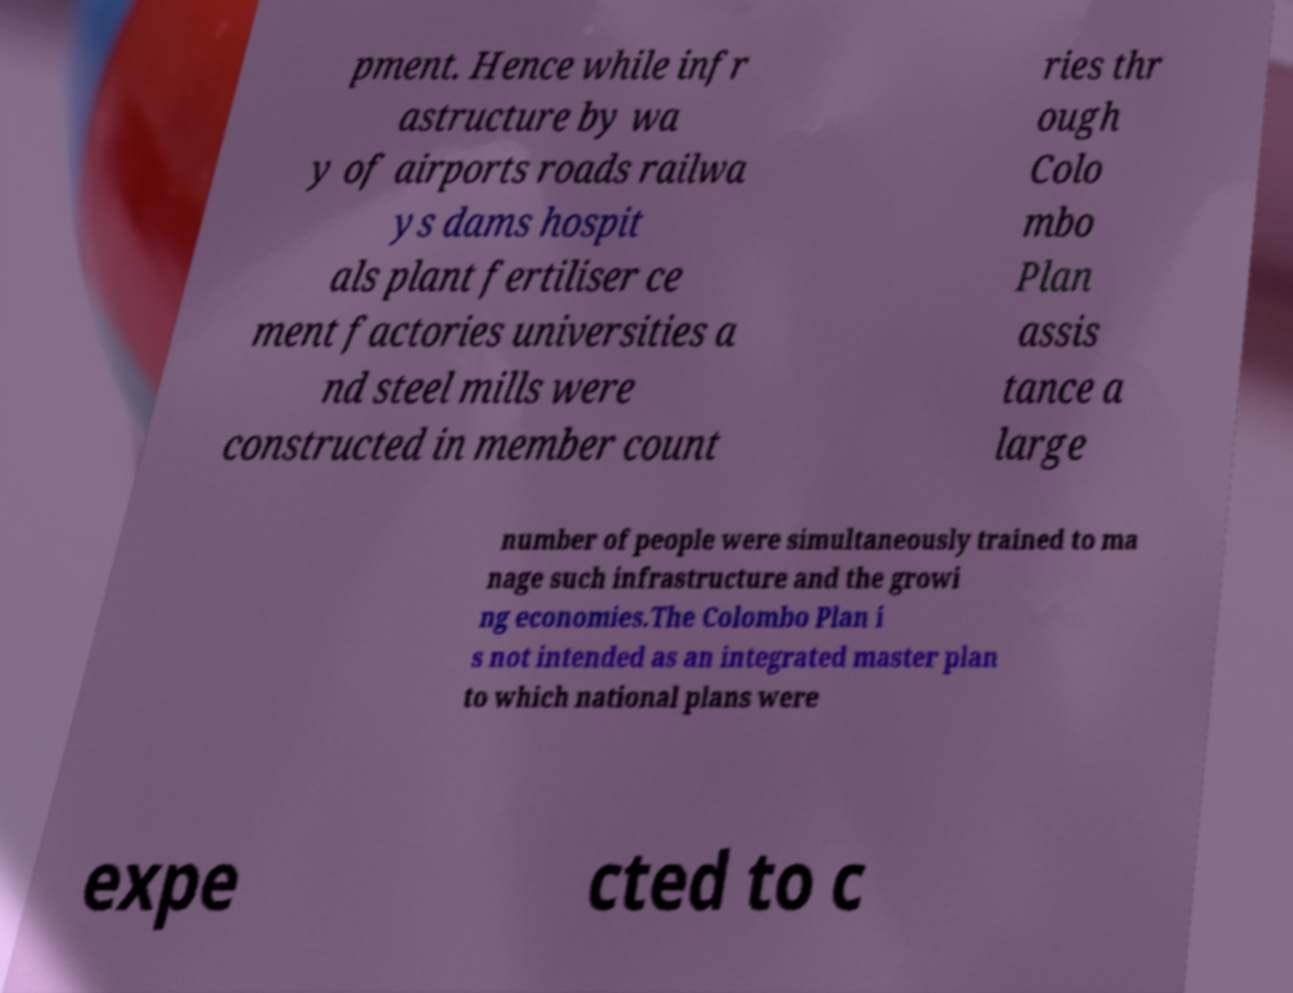For documentation purposes, I need the text within this image transcribed. Could you provide that? pment. Hence while infr astructure by wa y of airports roads railwa ys dams hospit als plant fertiliser ce ment factories universities a nd steel mills were constructed in member count ries thr ough Colo mbo Plan assis tance a large number of people were simultaneously trained to ma nage such infrastructure and the growi ng economies.The Colombo Plan i s not intended as an integrated master plan to which national plans were expe cted to c 